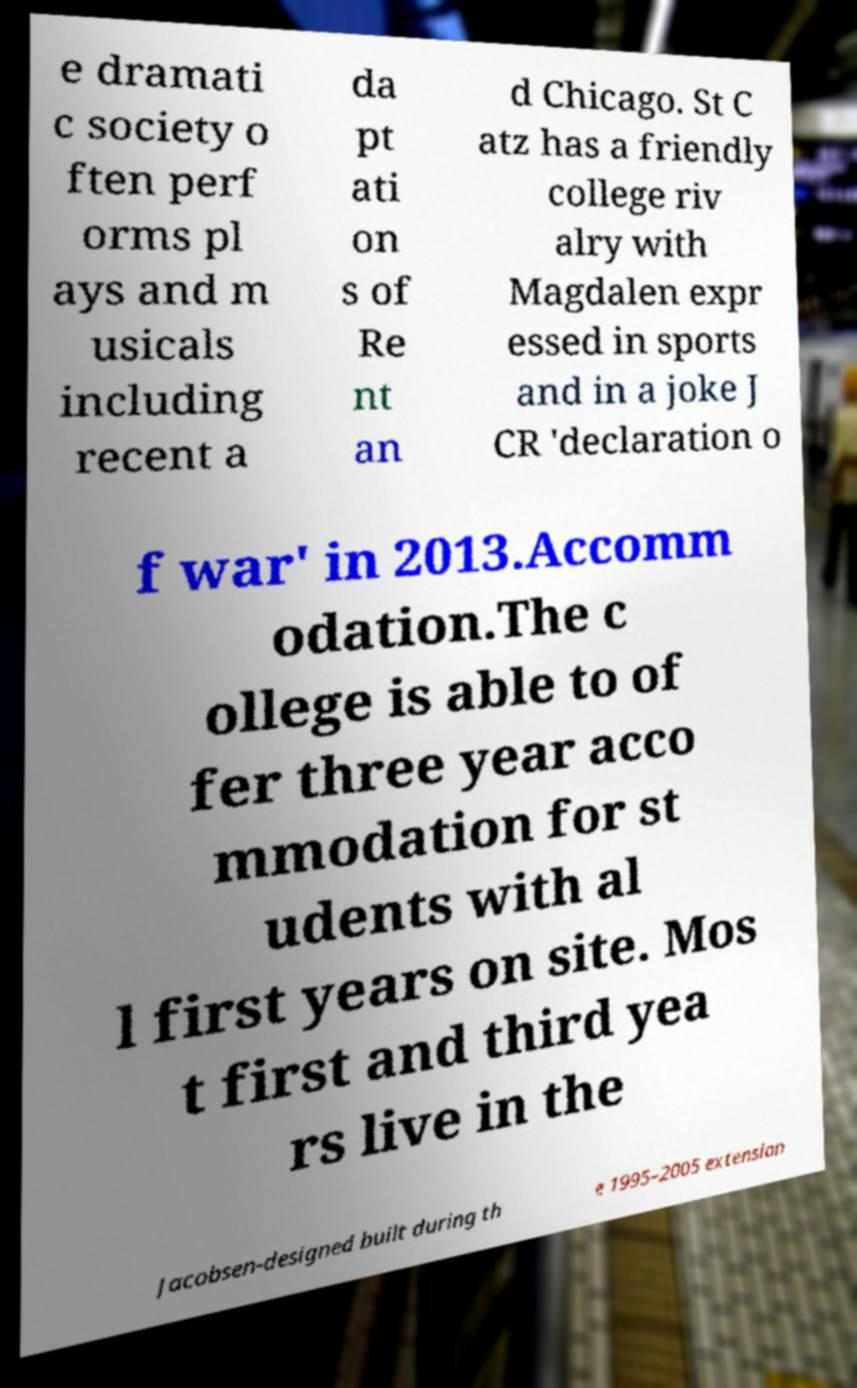Could you extract and type out the text from this image? e dramati c society o ften perf orms pl ays and m usicals including recent a da pt ati on s of Re nt an d Chicago. St C atz has a friendly college riv alry with Magdalen expr essed in sports and in a joke J CR 'declaration o f war' in 2013.Accomm odation.The c ollege is able to of fer three year acco mmodation for st udents with al l first years on site. Mos t first and third yea rs live in the Jacobsen-designed built during th e 1995–2005 extension 